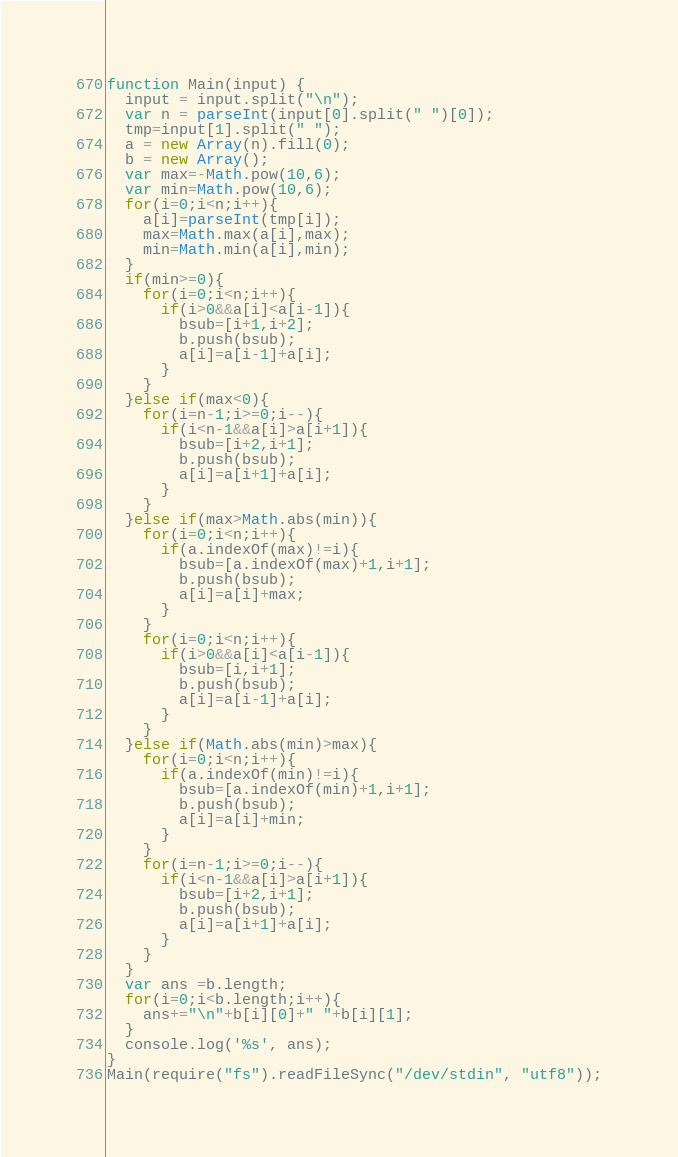<code> <loc_0><loc_0><loc_500><loc_500><_JavaScript_>function Main(input) {
  input = input.split("\n");
  var n = parseInt(input[0].split(" ")[0]);
  tmp=input[1].split(" ");
  a = new Array(n).fill(0);
  b = new Array();
  var max=-Math.pow(10,6);
  var min=Math.pow(10,6);
  for(i=0;i<n;i++){
    a[i]=parseInt(tmp[i]);
    max=Math.max(a[i],max);
    min=Math.min(a[i],min);
  }
  if(min>=0){
    for(i=0;i<n;i++){
      if(i>0&&a[i]<a[i-1]){
        bsub=[i+1,i+2];
        b.push(bsub);
        a[i]=a[i-1]+a[i];
      }
    }
  }else if(max<0){
    for(i=n-1;i>=0;i--){
      if(i<n-1&&a[i]>a[i+1]){
        bsub=[i+2,i+1];
        b.push(bsub);
        a[i]=a[i+1]+a[i];
      }
    }
  }else if(max>Math.abs(min)){
    for(i=0;i<n;i++){
      if(a.indexOf(max)!=i){
        bsub=[a.indexOf(max)+1,i+1];
        b.push(bsub);
        a[i]=a[i]+max;
      }
    }
    for(i=0;i<n;i++){
      if(i>0&&a[i]<a[i-1]){
        bsub=[i,i+1];
        b.push(bsub);
        a[i]=a[i-1]+a[i];
      }
    }
  }else if(Math.abs(min)>max){
    for(i=0;i<n;i++){
      if(a.indexOf(min)!=i){
        bsub=[a.indexOf(min)+1,i+1];
        b.push(bsub);
        a[i]=a[i]+min;
      }
    }
    for(i=n-1;i>=0;i--){
      if(i<n-1&&a[i]>a[i+1]){
        bsub=[i+2,i+1];
        b.push(bsub);
        a[i]=a[i+1]+a[i];
      }
    }
  }
  var ans =b.length;
  for(i=0;i<b.length;i++){
    ans+="\n"+b[i][0]+" "+b[i][1];
  }
  console.log('%s', ans);
}
Main(require("fs").readFileSync("/dev/stdin", "utf8"));</code> 